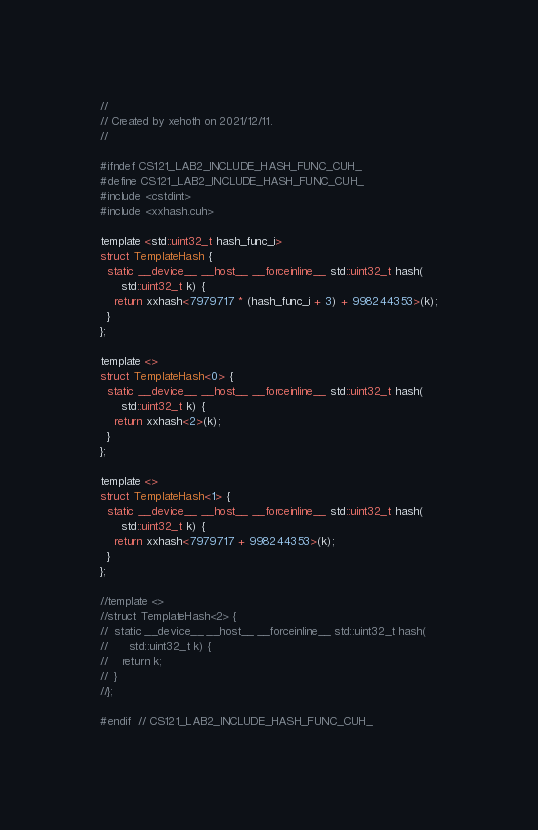<code> <loc_0><loc_0><loc_500><loc_500><_Cuda_>//
// Created by xehoth on 2021/12/11.
//

#ifndef CS121_LAB2_INCLUDE_HASH_FUNC_CUH_
#define CS121_LAB2_INCLUDE_HASH_FUNC_CUH_
#include <cstdint>
#include <xxhash.cuh>

template <std::uint32_t hash_func_i>
struct TemplateHash {
  static __device__ __host__ __forceinline__ std::uint32_t hash(
      std::uint32_t k) {
    return xxhash<7979717 * (hash_func_i + 3) + 998244353>(k);
  }
};

template <>
struct TemplateHash<0> {
  static __device__ __host__ __forceinline__ std::uint32_t hash(
      std::uint32_t k) {
    return xxhash<2>(k);
  }
};

template <>
struct TemplateHash<1> {
  static __device__ __host__ __forceinline__ std::uint32_t hash(
      std::uint32_t k) {
    return xxhash<7979717 + 998244353>(k);
  }
};

//template <>
//struct TemplateHash<2> {
//  static __device__ __host__ __forceinline__ std::uint32_t hash(
//      std::uint32_t k) {
//    return k;
//  }
//};

#endif  // CS121_LAB2_INCLUDE_HASH_FUNC_CUH_
</code> 